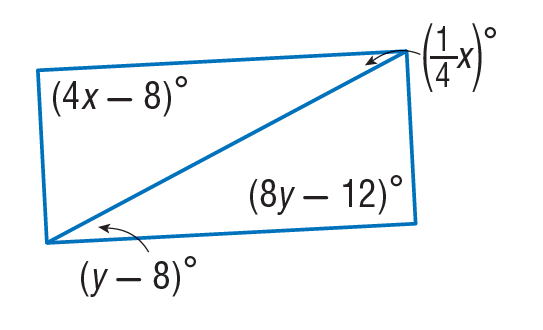Question: Find y so that the quadrilateral is a parallelogram.
Choices:
A. 9
B. 12
C. 15.5
D. 31
Answer with the letter. Answer: C Question: Find x so that the quadrilateral is a parallelogram.
Choices:
A. 28
B. 30
C. 90
D. 112
Answer with the letter. Answer: B 